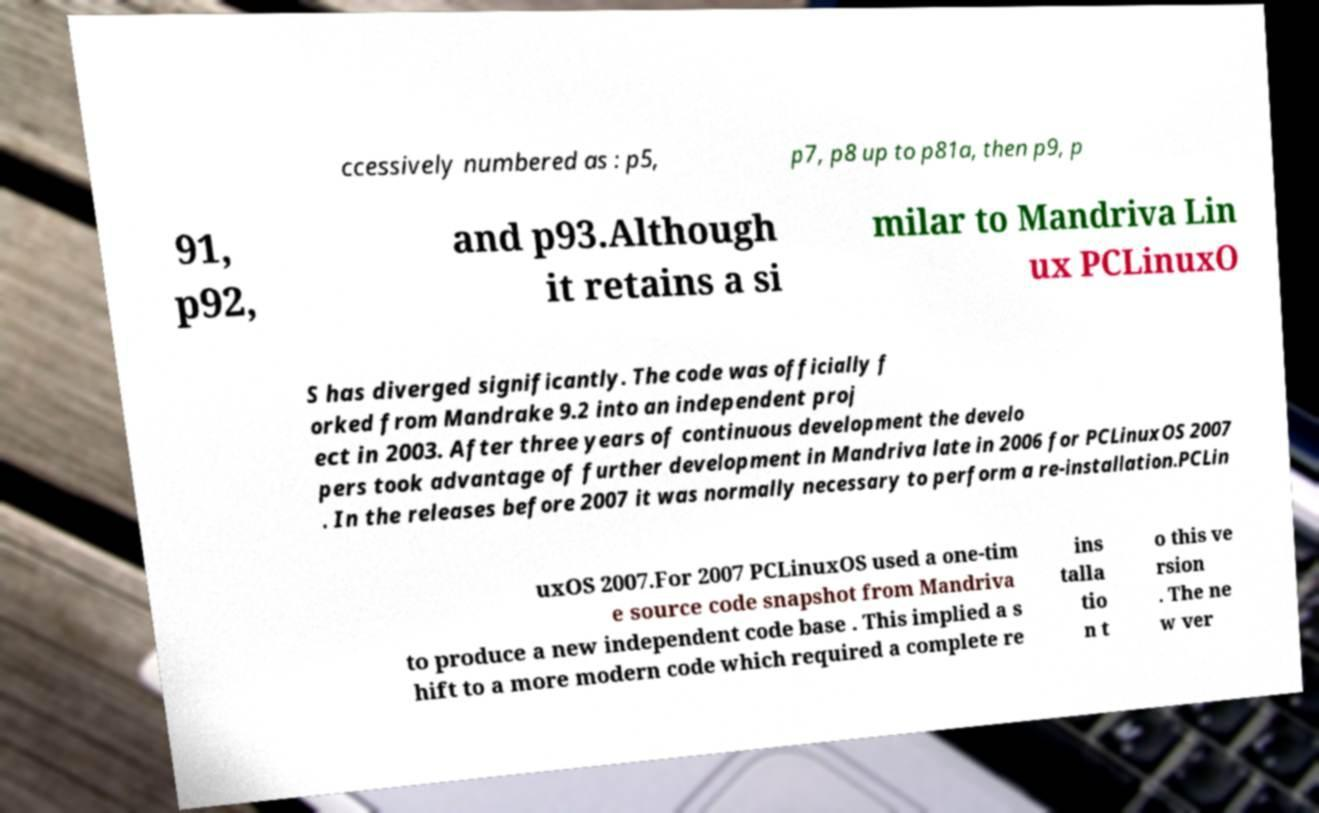Could you extract and type out the text from this image? ccessively numbered as : p5, p7, p8 up to p81a, then p9, p 91, p92, and p93.Although it retains a si milar to Mandriva Lin ux PCLinuxO S has diverged significantly. The code was officially f orked from Mandrake 9.2 into an independent proj ect in 2003. After three years of continuous development the develo pers took advantage of further development in Mandriva late in 2006 for PCLinuxOS 2007 . In the releases before 2007 it was normally necessary to perform a re-installation.PCLin uxOS 2007.For 2007 PCLinuxOS used a one-tim e source code snapshot from Mandriva to produce a new independent code base . This implied a s hift to a more modern code which required a complete re ins talla tio n t o this ve rsion . The ne w ver 